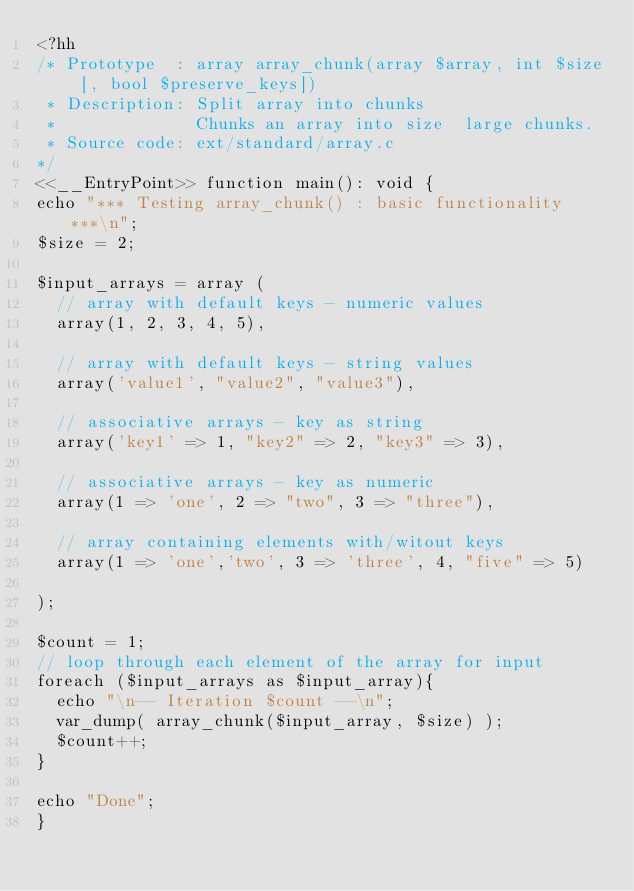Convert code to text. <code><loc_0><loc_0><loc_500><loc_500><_PHP_><?hh
/* Prototype  : array array_chunk(array $array, int $size [, bool $preserve_keys])
 * Description: Split array into chunks
 *              Chunks an array into size  large chunks.
 * Source code: ext/standard/array.c
*/
<<__EntryPoint>> function main(): void {
echo "*** Testing array_chunk() : basic functionality ***\n";
$size = 2;

$input_arrays = array (
  // array with default keys - numeric values
  array(1, 2, 3, 4, 5),

  // array with default keys - string values
  array('value1', "value2", "value3"),

  // associative arrays - key as string
  array('key1' => 1, "key2" => 2, "key3" => 3),
 
  // associative arrays - key as numeric
  array(1 => 'one', 2 => "two", 3 => "three"),

  // array containing elements with/witout keys 
  array(1 => 'one','two', 3 => 'three', 4, "five" => 5)

); 

$count = 1;
// loop through each element of the array for input
foreach ($input_arrays as $input_array){ 
  echo "\n-- Iteration $count --\n";  
  var_dump( array_chunk($input_array, $size) );
  $count++;
}

echo "Done";
}
</code> 